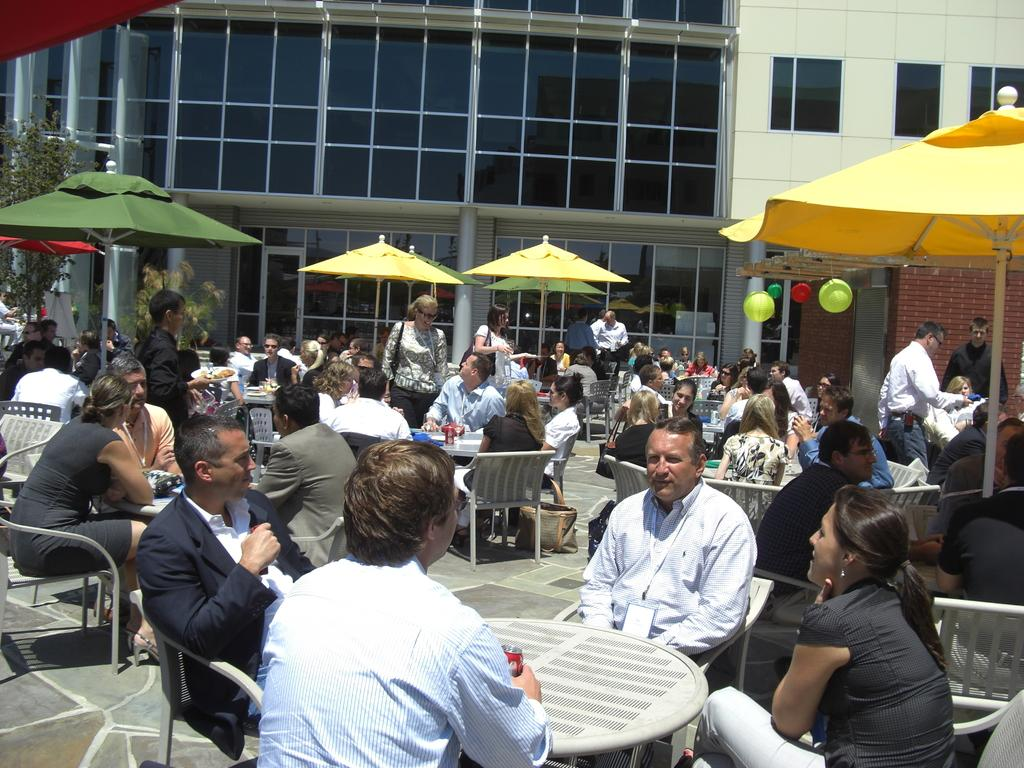What type of establishment is shown in the image? There is a restaurant in the image. How many people are present in the restaurant? Many people are sitting in the restaurant. What is provided for each person in the restaurant? Each person has a table in front of them. What other structures can be seen in the image? There are tents and a building beside the restaurant. What type of pet can be seen playing with a war toy in the image? There is no pet or war toy present in the image. 